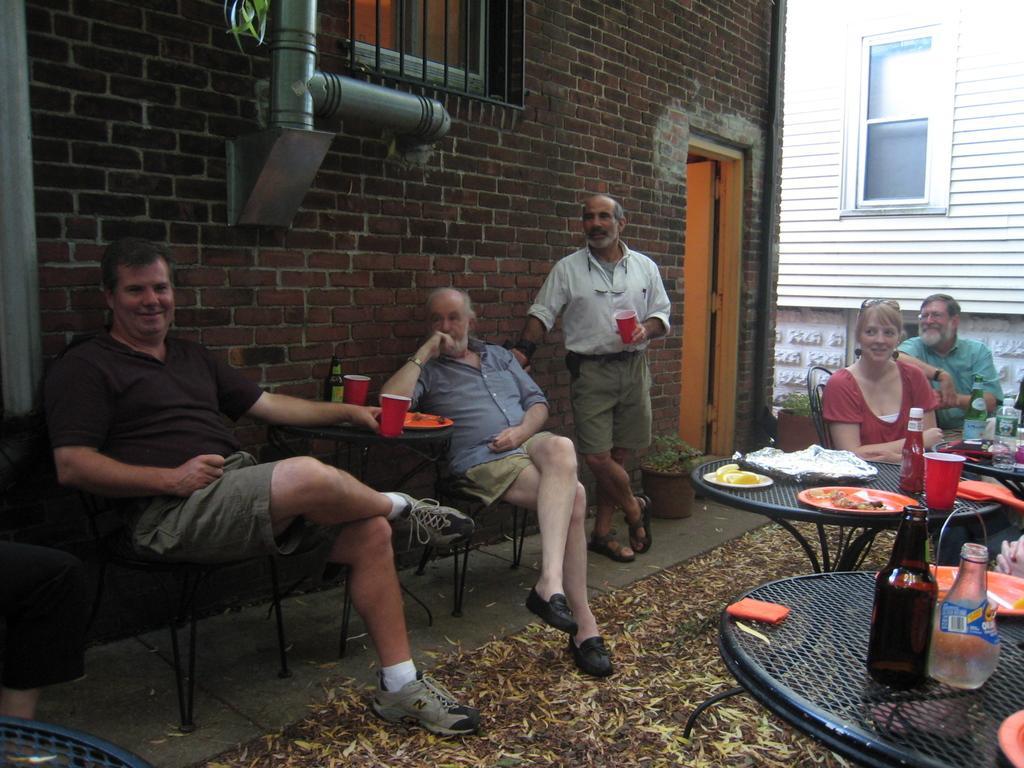Could you give a brief overview of what you see in this image? In this image there are some people sitting and one person is standing, in the center and he is holding something and also we could see some tables. On the tables there are some bottles, plates, spoons and some objects. At the bottom there is a carpet on the floor and in the background there are buildings, windows, pipe, door and some objects. 